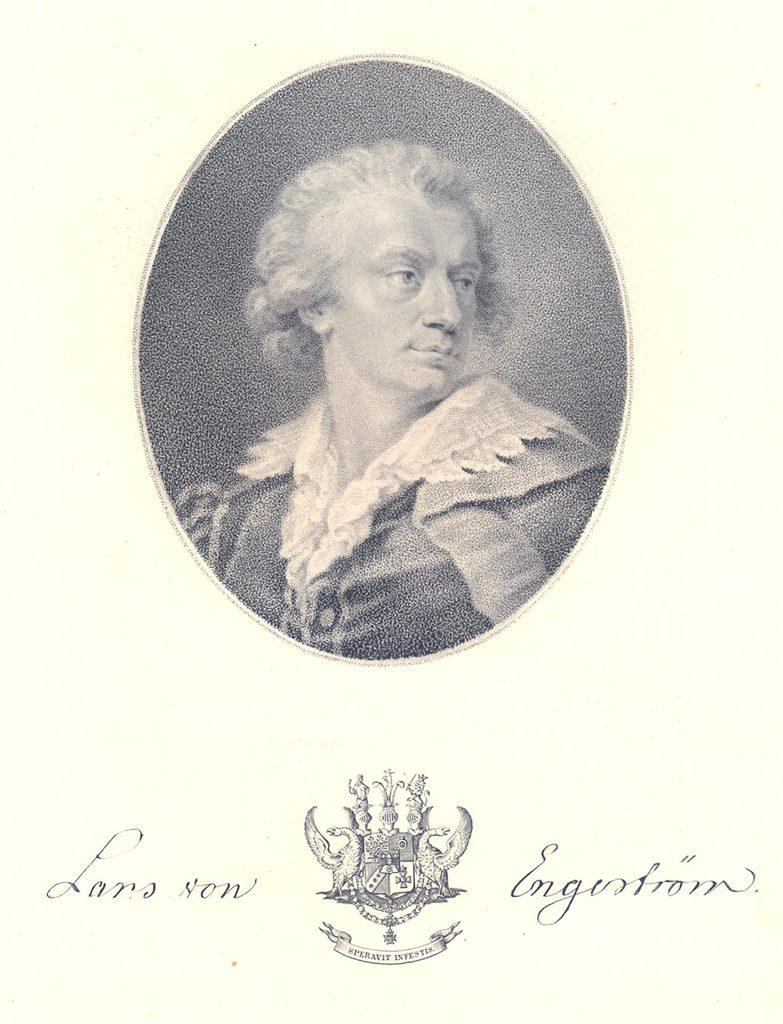What is the main object in the image? There is a paper in the image. What is depicted on the paper? There is a person with a dress depicted on the paper. What else can be found on the paper? Text is written on the paper, and there is a symbol on the paper. What news is being discussed by the person with a dress in the image? There is no discussion or news depicted in the image; it only shows a person with a dress on a paper with text and a symbol. 